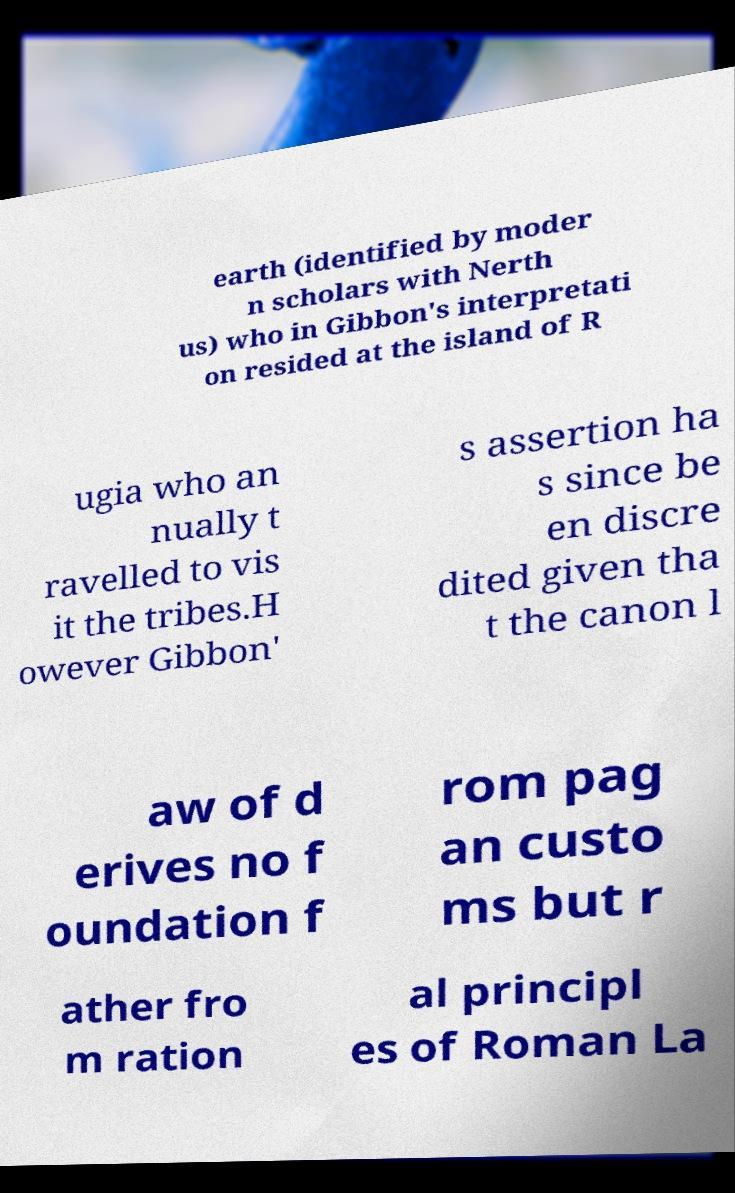Could you extract and type out the text from this image? earth (identified by moder n scholars with Nerth us) who in Gibbon's interpretati on resided at the island of R ugia who an nually t ravelled to vis it the tribes.H owever Gibbon' s assertion ha s since be en discre dited given tha t the canon l aw of d erives no f oundation f rom pag an custo ms but r ather fro m ration al principl es of Roman La 